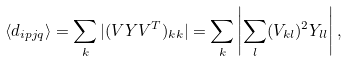<formula> <loc_0><loc_0><loc_500><loc_500>\langle d _ { i p j q } \rangle = \sum _ { k } | ( V Y V ^ { T } ) _ { k k } | = \sum _ { k } \left | \sum _ { l } ( V _ { k l } ) ^ { 2 } Y _ { l l } \right | ,</formula> 